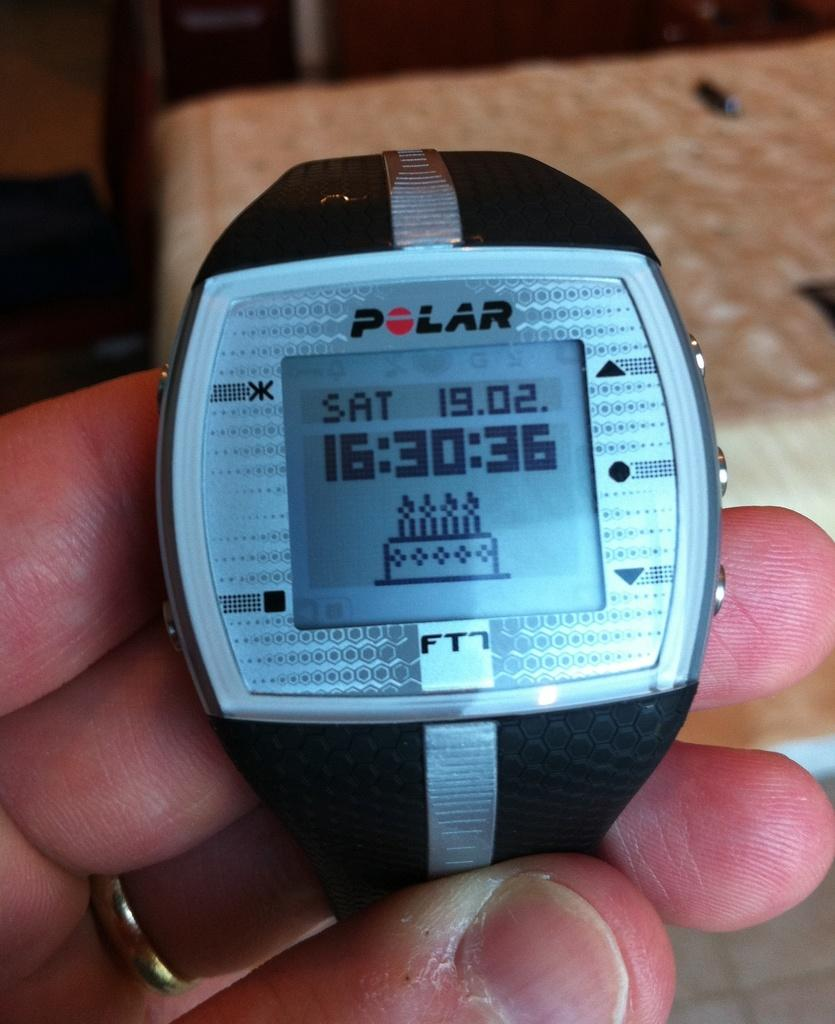Provide a one-sentence caption for the provided image. A Polar FT watch that have the time and day. 